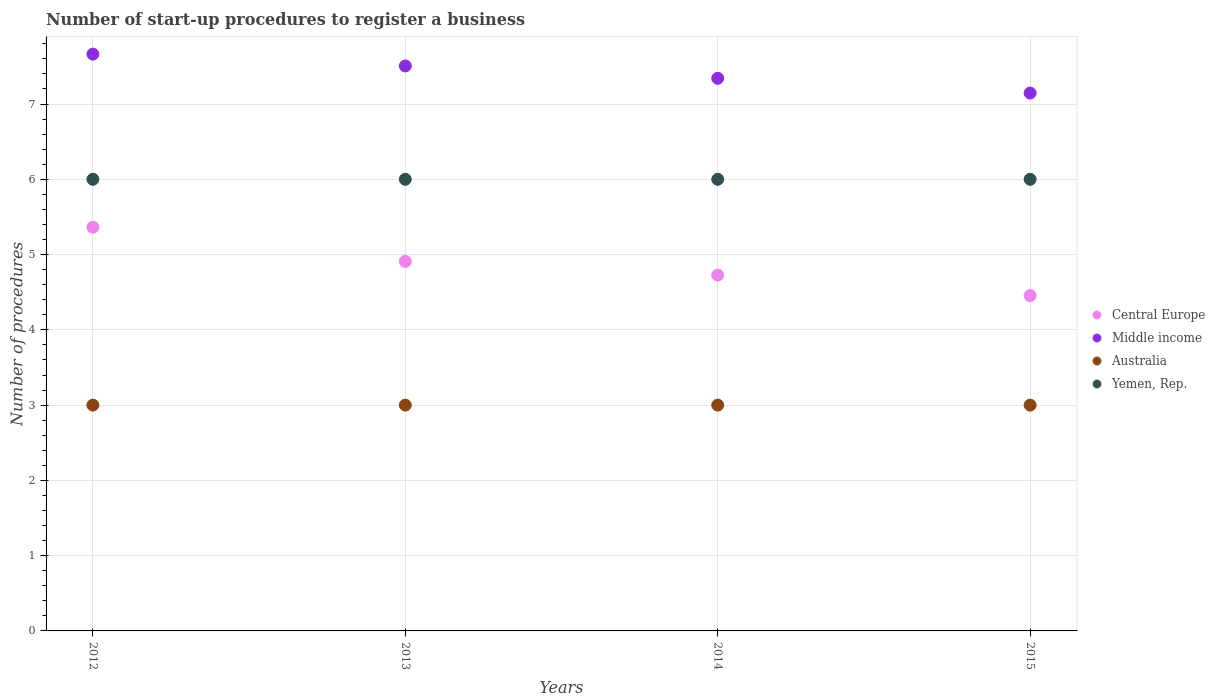Is the number of dotlines equal to the number of legend labels?
Make the answer very short. Yes. Across all years, what is the maximum number of procedures required to register a business in Middle income?
Your answer should be very brief. 7.66. Across all years, what is the minimum number of procedures required to register a business in Yemen, Rep.?
Ensure brevity in your answer.  6. In which year was the number of procedures required to register a business in Central Europe minimum?
Provide a short and direct response. 2015. What is the total number of procedures required to register a business in Central Europe in the graph?
Keep it short and to the point. 19.45. What is the difference between the number of procedures required to register a business in Australia in 2012 and that in 2014?
Provide a succinct answer. 0. What is the difference between the number of procedures required to register a business in Central Europe in 2013 and the number of procedures required to register a business in Yemen, Rep. in 2012?
Your answer should be very brief. -1.09. What is the average number of procedures required to register a business in Australia per year?
Keep it short and to the point. 3. In the year 2012, what is the difference between the number of procedures required to register a business in Australia and number of procedures required to register a business in Yemen, Rep.?
Your answer should be compact. -3. What is the ratio of the number of procedures required to register a business in Central Europe in 2012 to that in 2013?
Offer a terse response. 1.09. What is the difference between the highest and the second highest number of procedures required to register a business in Yemen, Rep.?
Offer a terse response. 0. What is the difference between the highest and the lowest number of procedures required to register a business in Middle income?
Provide a short and direct response. 0.52. Is the sum of the number of procedures required to register a business in Middle income in 2012 and 2014 greater than the maximum number of procedures required to register a business in Australia across all years?
Offer a very short reply. Yes. Is it the case that in every year, the sum of the number of procedures required to register a business in Australia and number of procedures required to register a business in Middle income  is greater than the sum of number of procedures required to register a business in Central Europe and number of procedures required to register a business in Yemen, Rep.?
Your answer should be compact. No. Is the number of procedures required to register a business in Yemen, Rep. strictly less than the number of procedures required to register a business in Australia over the years?
Keep it short and to the point. No. How many dotlines are there?
Offer a terse response. 4. What is the difference between two consecutive major ticks on the Y-axis?
Your response must be concise. 1. Are the values on the major ticks of Y-axis written in scientific E-notation?
Your answer should be very brief. No. Does the graph contain any zero values?
Give a very brief answer. No. Does the graph contain grids?
Make the answer very short. Yes. How many legend labels are there?
Give a very brief answer. 4. How are the legend labels stacked?
Give a very brief answer. Vertical. What is the title of the graph?
Your answer should be compact. Number of start-up procedures to register a business. Does "Lower middle income" appear as one of the legend labels in the graph?
Provide a succinct answer. No. What is the label or title of the Y-axis?
Your answer should be compact. Number of procedures. What is the Number of procedures of Central Europe in 2012?
Offer a terse response. 5.36. What is the Number of procedures in Middle income in 2012?
Give a very brief answer. 7.66. What is the Number of procedures in Australia in 2012?
Your response must be concise. 3. What is the Number of procedures of Yemen, Rep. in 2012?
Provide a succinct answer. 6. What is the Number of procedures in Central Europe in 2013?
Provide a short and direct response. 4.91. What is the Number of procedures in Middle income in 2013?
Provide a short and direct response. 7.51. What is the Number of procedures of Australia in 2013?
Ensure brevity in your answer.  3. What is the Number of procedures of Central Europe in 2014?
Provide a short and direct response. 4.73. What is the Number of procedures of Middle income in 2014?
Make the answer very short. 7.34. What is the Number of procedures of Yemen, Rep. in 2014?
Ensure brevity in your answer.  6. What is the Number of procedures in Central Europe in 2015?
Offer a terse response. 4.45. What is the Number of procedures in Middle income in 2015?
Make the answer very short. 7.15. Across all years, what is the maximum Number of procedures in Central Europe?
Ensure brevity in your answer.  5.36. Across all years, what is the maximum Number of procedures in Middle income?
Make the answer very short. 7.66. Across all years, what is the maximum Number of procedures in Australia?
Keep it short and to the point. 3. Across all years, what is the minimum Number of procedures of Central Europe?
Provide a short and direct response. 4.45. Across all years, what is the minimum Number of procedures of Middle income?
Keep it short and to the point. 7.15. Across all years, what is the minimum Number of procedures of Yemen, Rep.?
Provide a succinct answer. 6. What is the total Number of procedures of Central Europe in the graph?
Ensure brevity in your answer.  19.45. What is the total Number of procedures in Middle income in the graph?
Provide a succinct answer. 29.66. What is the total Number of procedures in Australia in the graph?
Make the answer very short. 12. What is the total Number of procedures in Yemen, Rep. in the graph?
Your answer should be very brief. 24. What is the difference between the Number of procedures in Central Europe in 2012 and that in 2013?
Your answer should be compact. 0.45. What is the difference between the Number of procedures in Middle income in 2012 and that in 2013?
Ensure brevity in your answer.  0.16. What is the difference between the Number of procedures in Australia in 2012 and that in 2013?
Offer a terse response. 0. What is the difference between the Number of procedures of Central Europe in 2012 and that in 2014?
Provide a succinct answer. 0.64. What is the difference between the Number of procedures of Middle income in 2012 and that in 2014?
Provide a succinct answer. 0.32. What is the difference between the Number of procedures of Yemen, Rep. in 2012 and that in 2014?
Provide a succinct answer. 0. What is the difference between the Number of procedures in Middle income in 2012 and that in 2015?
Provide a short and direct response. 0.52. What is the difference between the Number of procedures in Australia in 2012 and that in 2015?
Your response must be concise. 0. What is the difference between the Number of procedures of Central Europe in 2013 and that in 2014?
Offer a terse response. 0.18. What is the difference between the Number of procedures in Middle income in 2013 and that in 2014?
Give a very brief answer. 0.16. What is the difference between the Number of procedures in Australia in 2013 and that in 2014?
Ensure brevity in your answer.  0. What is the difference between the Number of procedures in Yemen, Rep. in 2013 and that in 2014?
Make the answer very short. 0. What is the difference between the Number of procedures in Central Europe in 2013 and that in 2015?
Offer a terse response. 0.45. What is the difference between the Number of procedures in Middle income in 2013 and that in 2015?
Your answer should be compact. 0.36. What is the difference between the Number of procedures of Australia in 2013 and that in 2015?
Ensure brevity in your answer.  0. What is the difference between the Number of procedures of Yemen, Rep. in 2013 and that in 2015?
Provide a succinct answer. 0. What is the difference between the Number of procedures in Central Europe in 2014 and that in 2015?
Make the answer very short. 0.27. What is the difference between the Number of procedures of Middle income in 2014 and that in 2015?
Your answer should be very brief. 0.2. What is the difference between the Number of procedures of Australia in 2014 and that in 2015?
Your answer should be compact. 0. What is the difference between the Number of procedures in Central Europe in 2012 and the Number of procedures in Middle income in 2013?
Your answer should be very brief. -2.14. What is the difference between the Number of procedures of Central Europe in 2012 and the Number of procedures of Australia in 2013?
Provide a short and direct response. 2.36. What is the difference between the Number of procedures in Central Europe in 2012 and the Number of procedures in Yemen, Rep. in 2013?
Your answer should be very brief. -0.64. What is the difference between the Number of procedures in Middle income in 2012 and the Number of procedures in Australia in 2013?
Offer a terse response. 4.66. What is the difference between the Number of procedures of Middle income in 2012 and the Number of procedures of Yemen, Rep. in 2013?
Your response must be concise. 1.66. What is the difference between the Number of procedures in Australia in 2012 and the Number of procedures in Yemen, Rep. in 2013?
Keep it short and to the point. -3. What is the difference between the Number of procedures in Central Europe in 2012 and the Number of procedures in Middle income in 2014?
Offer a very short reply. -1.98. What is the difference between the Number of procedures of Central Europe in 2012 and the Number of procedures of Australia in 2014?
Make the answer very short. 2.36. What is the difference between the Number of procedures of Central Europe in 2012 and the Number of procedures of Yemen, Rep. in 2014?
Ensure brevity in your answer.  -0.64. What is the difference between the Number of procedures in Middle income in 2012 and the Number of procedures in Australia in 2014?
Offer a terse response. 4.66. What is the difference between the Number of procedures of Middle income in 2012 and the Number of procedures of Yemen, Rep. in 2014?
Provide a short and direct response. 1.66. What is the difference between the Number of procedures of Australia in 2012 and the Number of procedures of Yemen, Rep. in 2014?
Provide a short and direct response. -3. What is the difference between the Number of procedures of Central Europe in 2012 and the Number of procedures of Middle income in 2015?
Make the answer very short. -1.78. What is the difference between the Number of procedures in Central Europe in 2012 and the Number of procedures in Australia in 2015?
Make the answer very short. 2.36. What is the difference between the Number of procedures of Central Europe in 2012 and the Number of procedures of Yemen, Rep. in 2015?
Ensure brevity in your answer.  -0.64. What is the difference between the Number of procedures of Middle income in 2012 and the Number of procedures of Australia in 2015?
Give a very brief answer. 4.66. What is the difference between the Number of procedures in Middle income in 2012 and the Number of procedures in Yemen, Rep. in 2015?
Your answer should be compact. 1.66. What is the difference between the Number of procedures in Central Europe in 2013 and the Number of procedures in Middle income in 2014?
Your answer should be compact. -2.43. What is the difference between the Number of procedures in Central Europe in 2013 and the Number of procedures in Australia in 2014?
Give a very brief answer. 1.91. What is the difference between the Number of procedures of Central Europe in 2013 and the Number of procedures of Yemen, Rep. in 2014?
Make the answer very short. -1.09. What is the difference between the Number of procedures of Middle income in 2013 and the Number of procedures of Australia in 2014?
Your response must be concise. 4.51. What is the difference between the Number of procedures of Middle income in 2013 and the Number of procedures of Yemen, Rep. in 2014?
Ensure brevity in your answer.  1.51. What is the difference between the Number of procedures in Central Europe in 2013 and the Number of procedures in Middle income in 2015?
Provide a short and direct response. -2.24. What is the difference between the Number of procedures of Central Europe in 2013 and the Number of procedures of Australia in 2015?
Ensure brevity in your answer.  1.91. What is the difference between the Number of procedures of Central Europe in 2013 and the Number of procedures of Yemen, Rep. in 2015?
Your answer should be compact. -1.09. What is the difference between the Number of procedures in Middle income in 2013 and the Number of procedures in Australia in 2015?
Provide a short and direct response. 4.51. What is the difference between the Number of procedures of Middle income in 2013 and the Number of procedures of Yemen, Rep. in 2015?
Provide a succinct answer. 1.51. What is the difference between the Number of procedures of Central Europe in 2014 and the Number of procedures of Middle income in 2015?
Ensure brevity in your answer.  -2.42. What is the difference between the Number of procedures in Central Europe in 2014 and the Number of procedures in Australia in 2015?
Your answer should be compact. 1.73. What is the difference between the Number of procedures of Central Europe in 2014 and the Number of procedures of Yemen, Rep. in 2015?
Offer a terse response. -1.27. What is the difference between the Number of procedures in Middle income in 2014 and the Number of procedures in Australia in 2015?
Offer a very short reply. 4.34. What is the difference between the Number of procedures in Middle income in 2014 and the Number of procedures in Yemen, Rep. in 2015?
Give a very brief answer. 1.34. What is the average Number of procedures of Central Europe per year?
Provide a succinct answer. 4.86. What is the average Number of procedures in Middle income per year?
Your answer should be compact. 7.41. In the year 2012, what is the difference between the Number of procedures of Central Europe and Number of procedures of Middle income?
Keep it short and to the point. -2.3. In the year 2012, what is the difference between the Number of procedures of Central Europe and Number of procedures of Australia?
Keep it short and to the point. 2.36. In the year 2012, what is the difference between the Number of procedures in Central Europe and Number of procedures in Yemen, Rep.?
Your answer should be very brief. -0.64. In the year 2012, what is the difference between the Number of procedures of Middle income and Number of procedures of Australia?
Your response must be concise. 4.66. In the year 2012, what is the difference between the Number of procedures of Middle income and Number of procedures of Yemen, Rep.?
Ensure brevity in your answer.  1.66. In the year 2013, what is the difference between the Number of procedures in Central Europe and Number of procedures in Middle income?
Give a very brief answer. -2.6. In the year 2013, what is the difference between the Number of procedures in Central Europe and Number of procedures in Australia?
Provide a succinct answer. 1.91. In the year 2013, what is the difference between the Number of procedures of Central Europe and Number of procedures of Yemen, Rep.?
Give a very brief answer. -1.09. In the year 2013, what is the difference between the Number of procedures in Middle income and Number of procedures in Australia?
Your response must be concise. 4.51. In the year 2013, what is the difference between the Number of procedures of Middle income and Number of procedures of Yemen, Rep.?
Ensure brevity in your answer.  1.51. In the year 2014, what is the difference between the Number of procedures of Central Europe and Number of procedures of Middle income?
Provide a short and direct response. -2.61. In the year 2014, what is the difference between the Number of procedures of Central Europe and Number of procedures of Australia?
Give a very brief answer. 1.73. In the year 2014, what is the difference between the Number of procedures in Central Europe and Number of procedures in Yemen, Rep.?
Your response must be concise. -1.27. In the year 2014, what is the difference between the Number of procedures in Middle income and Number of procedures in Australia?
Your response must be concise. 4.34. In the year 2014, what is the difference between the Number of procedures in Middle income and Number of procedures in Yemen, Rep.?
Your response must be concise. 1.34. In the year 2014, what is the difference between the Number of procedures of Australia and Number of procedures of Yemen, Rep.?
Provide a short and direct response. -3. In the year 2015, what is the difference between the Number of procedures in Central Europe and Number of procedures in Middle income?
Your answer should be compact. -2.69. In the year 2015, what is the difference between the Number of procedures in Central Europe and Number of procedures in Australia?
Your response must be concise. 1.45. In the year 2015, what is the difference between the Number of procedures in Central Europe and Number of procedures in Yemen, Rep.?
Offer a very short reply. -1.55. In the year 2015, what is the difference between the Number of procedures of Middle income and Number of procedures of Australia?
Your response must be concise. 4.15. In the year 2015, what is the difference between the Number of procedures of Middle income and Number of procedures of Yemen, Rep.?
Give a very brief answer. 1.15. In the year 2015, what is the difference between the Number of procedures of Australia and Number of procedures of Yemen, Rep.?
Your response must be concise. -3. What is the ratio of the Number of procedures in Central Europe in 2012 to that in 2013?
Give a very brief answer. 1.09. What is the ratio of the Number of procedures in Middle income in 2012 to that in 2013?
Provide a succinct answer. 1.02. What is the ratio of the Number of procedures of Central Europe in 2012 to that in 2014?
Give a very brief answer. 1.13. What is the ratio of the Number of procedures of Middle income in 2012 to that in 2014?
Your answer should be very brief. 1.04. What is the ratio of the Number of procedures in Yemen, Rep. in 2012 to that in 2014?
Give a very brief answer. 1. What is the ratio of the Number of procedures of Central Europe in 2012 to that in 2015?
Your answer should be compact. 1.2. What is the ratio of the Number of procedures of Middle income in 2012 to that in 2015?
Keep it short and to the point. 1.07. What is the ratio of the Number of procedures in Australia in 2012 to that in 2015?
Make the answer very short. 1. What is the ratio of the Number of procedures of Central Europe in 2013 to that in 2014?
Your answer should be compact. 1.04. What is the ratio of the Number of procedures of Middle income in 2013 to that in 2014?
Give a very brief answer. 1.02. What is the ratio of the Number of procedures of Australia in 2013 to that in 2014?
Ensure brevity in your answer.  1. What is the ratio of the Number of procedures of Yemen, Rep. in 2013 to that in 2014?
Provide a short and direct response. 1. What is the ratio of the Number of procedures in Central Europe in 2013 to that in 2015?
Keep it short and to the point. 1.1. What is the ratio of the Number of procedures of Middle income in 2013 to that in 2015?
Give a very brief answer. 1.05. What is the ratio of the Number of procedures of Australia in 2013 to that in 2015?
Provide a succinct answer. 1. What is the ratio of the Number of procedures of Yemen, Rep. in 2013 to that in 2015?
Keep it short and to the point. 1. What is the ratio of the Number of procedures of Central Europe in 2014 to that in 2015?
Provide a short and direct response. 1.06. What is the ratio of the Number of procedures in Middle income in 2014 to that in 2015?
Your answer should be compact. 1.03. What is the ratio of the Number of procedures in Australia in 2014 to that in 2015?
Your answer should be very brief. 1. What is the difference between the highest and the second highest Number of procedures of Central Europe?
Provide a succinct answer. 0.45. What is the difference between the highest and the second highest Number of procedures in Middle income?
Your response must be concise. 0.16. What is the difference between the highest and the lowest Number of procedures in Central Europe?
Your answer should be compact. 0.91. What is the difference between the highest and the lowest Number of procedures in Middle income?
Ensure brevity in your answer.  0.52. What is the difference between the highest and the lowest Number of procedures in Australia?
Offer a terse response. 0. What is the difference between the highest and the lowest Number of procedures of Yemen, Rep.?
Your response must be concise. 0. 